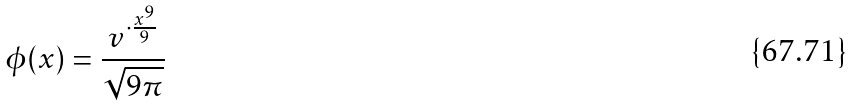Convert formula to latex. <formula><loc_0><loc_0><loc_500><loc_500>\phi ( x ) = \frac { v ^ { \cdot \frac { x ^ { 9 } } { 9 } } } { \sqrt { 9 \pi } }</formula> 